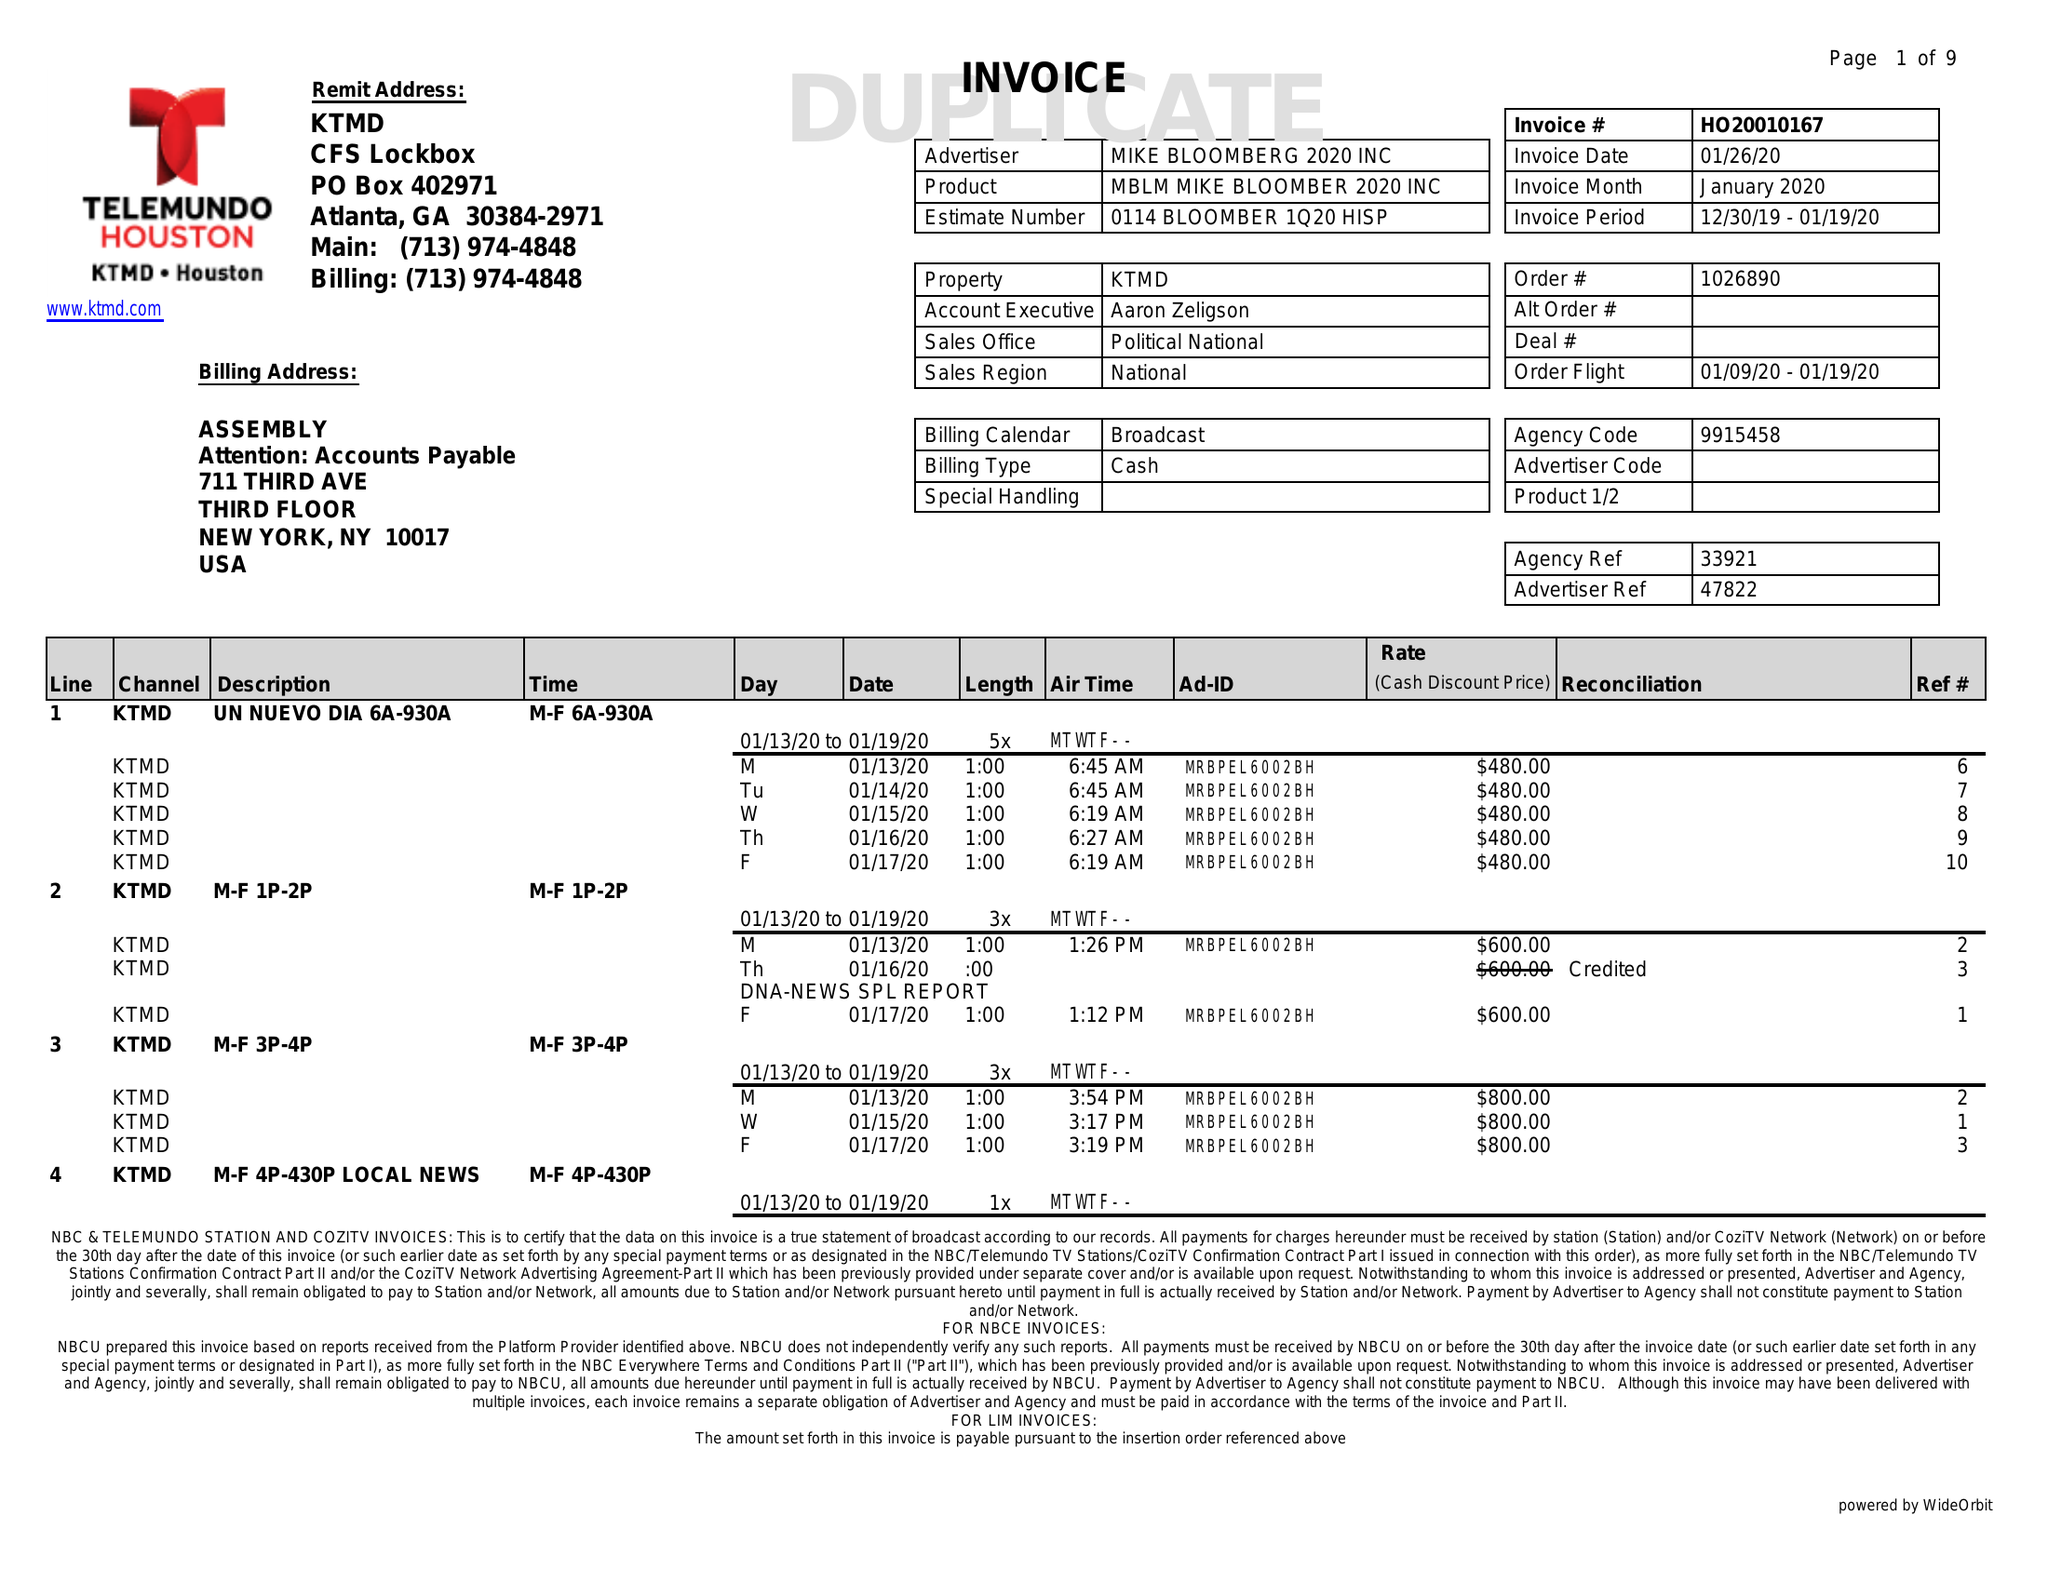What is the value for the flight_from?
Answer the question using a single word or phrase. 01/09/20 